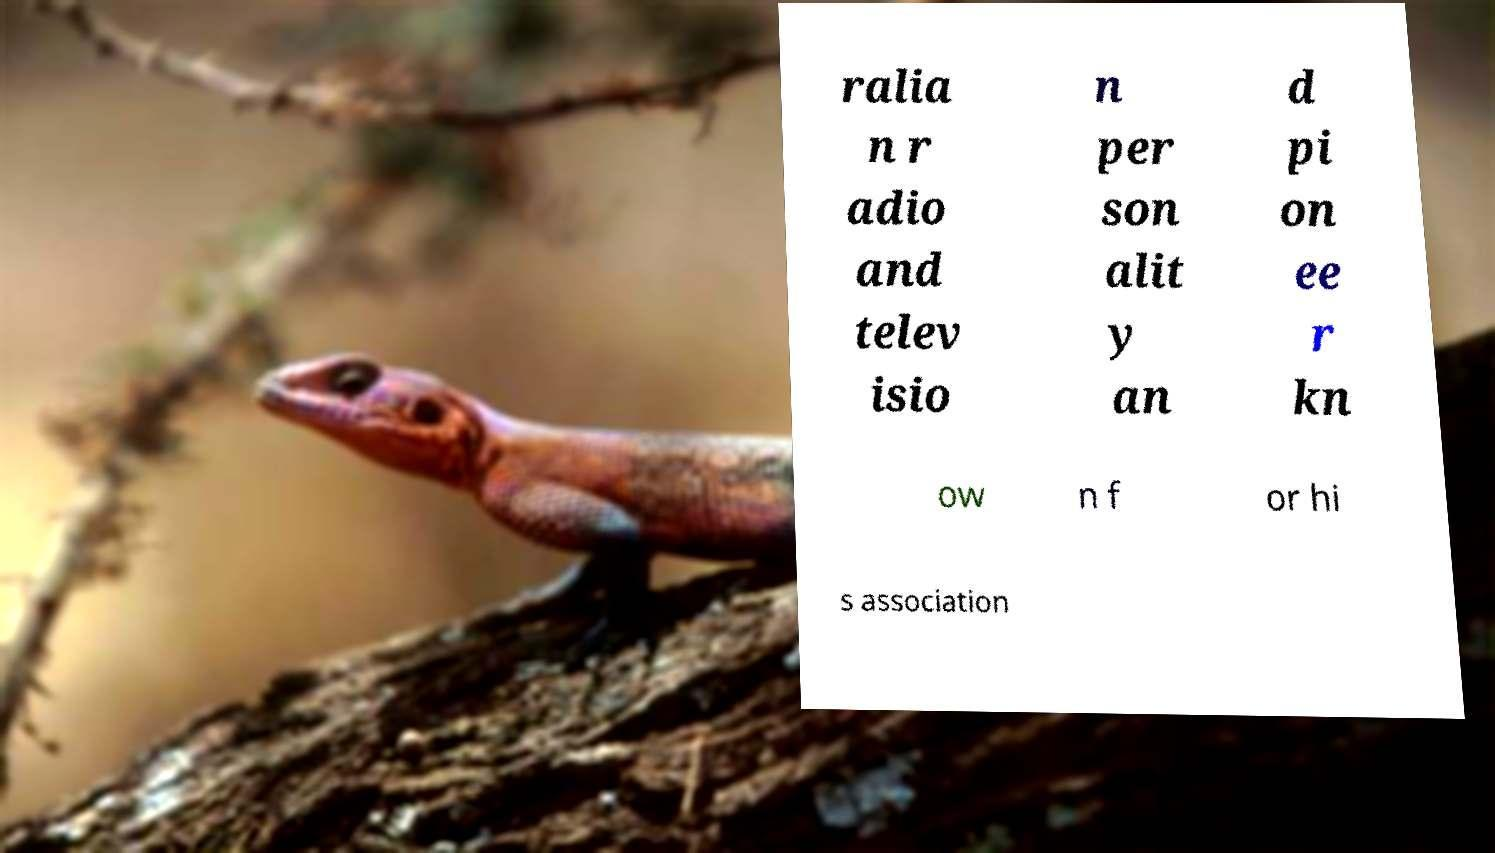I need the written content from this picture converted into text. Can you do that? ralia n r adio and telev isio n per son alit y an d pi on ee r kn ow n f or hi s association 